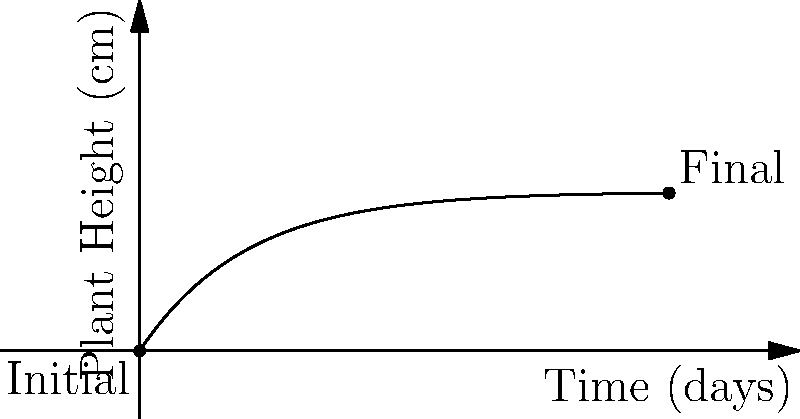In a time-lapse video of plant growth, you observe an exponential growth pattern. If the plant's height $h$ (in cm) at time $t$ (in days) follows the equation $h(t) = 3(1-e^{-0.5t})$, what computer vision technique would you use to estimate the growth rate, and what is the estimated final height of the plant after 10 days? To estimate the plant growth rate from a time-lapse video using computer vision, we would follow these steps:

1. Use object detection and segmentation to isolate the plant in each frame.
2. Apply edge detection to find the plant's height in pixels for each frame.
3. Convert pixel measurements to real-world units (cm) using a reference object.
4. Plot the height measurements over time.
5. Fit an exponential curve to the data points using regression analysis.

The given equation $h(t) = 3(1-e^{-0.5t})$ represents the exponential growth model.

To find the final height after 10 days:

1. Substitute $t=10$ into the equation:
   $h(10) = 3(1-e^{-0.5(10)})$
2. Calculate:
   $h(10) = 3(1-e^{-5})$
   $h(10) = 3(1-0.0067)$
   $h(10) = 3(0.9933)$
   $h(10) = 2.98$ cm (rounded to 2 decimal places)

The estimated final height of the plant after 10 days is approximately 2.98 cm.
Answer: Regression analysis; 2.98 cm 